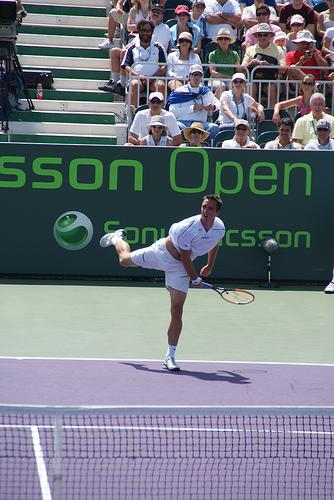What is the color of the tennis court surface and what is positioned on it? The tennis court is purple and lavender, and it has a tennis net with white edging. What are some spectators in the stands doing? One is playing with his camera, one is wearing a hat, another is talking on the phone. Which logos or advertisements are visible in the image? SonyEricsson logo, and green and lavender logo of the tournament. What objects are used for recording the tennis match? A television camera on the steps. Mention an object located on the steps near the tennis court. There is a bottle of sports drink on the steps. Describe the appearance of the woman in the red hat. She is wearing a blue sweater over her shoulders and a red hat on her head. Briefly describe the man in the red shirt. The man in the red shirt is looking at his phone. Point out a detail about the tennis net. The tennis net has a white tape and a mesh. List three objects or elements associated with the tennis player. Tennis racket, white tennis shorts, sweatband on the wrist. Identify the primary action taking place on the tennis court. A tennis player is on the court returning the ball. 